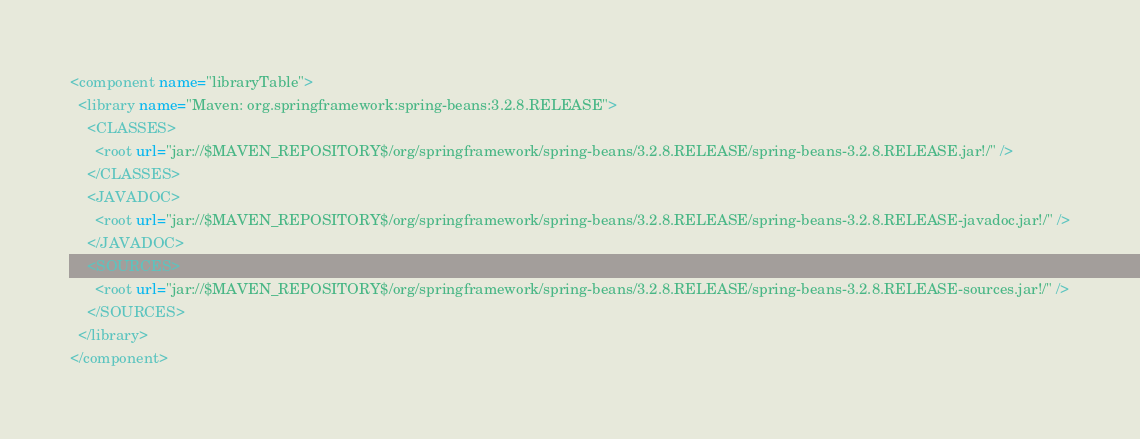<code> <loc_0><loc_0><loc_500><loc_500><_XML_><component name="libraryTable">
  <library name="Maven: org.springframework:spring-beans:3.2.8.RELEASE">
    <CLASSES>
      <root url="jar://$MAVEN_REPOSITORY$/org/springframework/spring-beans/3.2.8.RELEASE/spring-beans-3.2.8.RELEASE.jar!/" />
    </CLASSES>
    <JAVADOC>
      <root url="jar://$MAVEN_REPOSITORY$/org/springframework/spring-beans/3.2.8.RELEASE/spring-beans-3.2.8.RELEASE-javadoc.jar!/" />
    </JAVADOC>
    <SOURCES>
      <root url="jar://$MAVEN_REPOSITORY$/org/springframework/spring-beans/3.2.8.RELEASE/spring-beans-3.2.8.RELEASE-sources.jar!/" />
    </SOURCES>
  </library>
</component></code> 